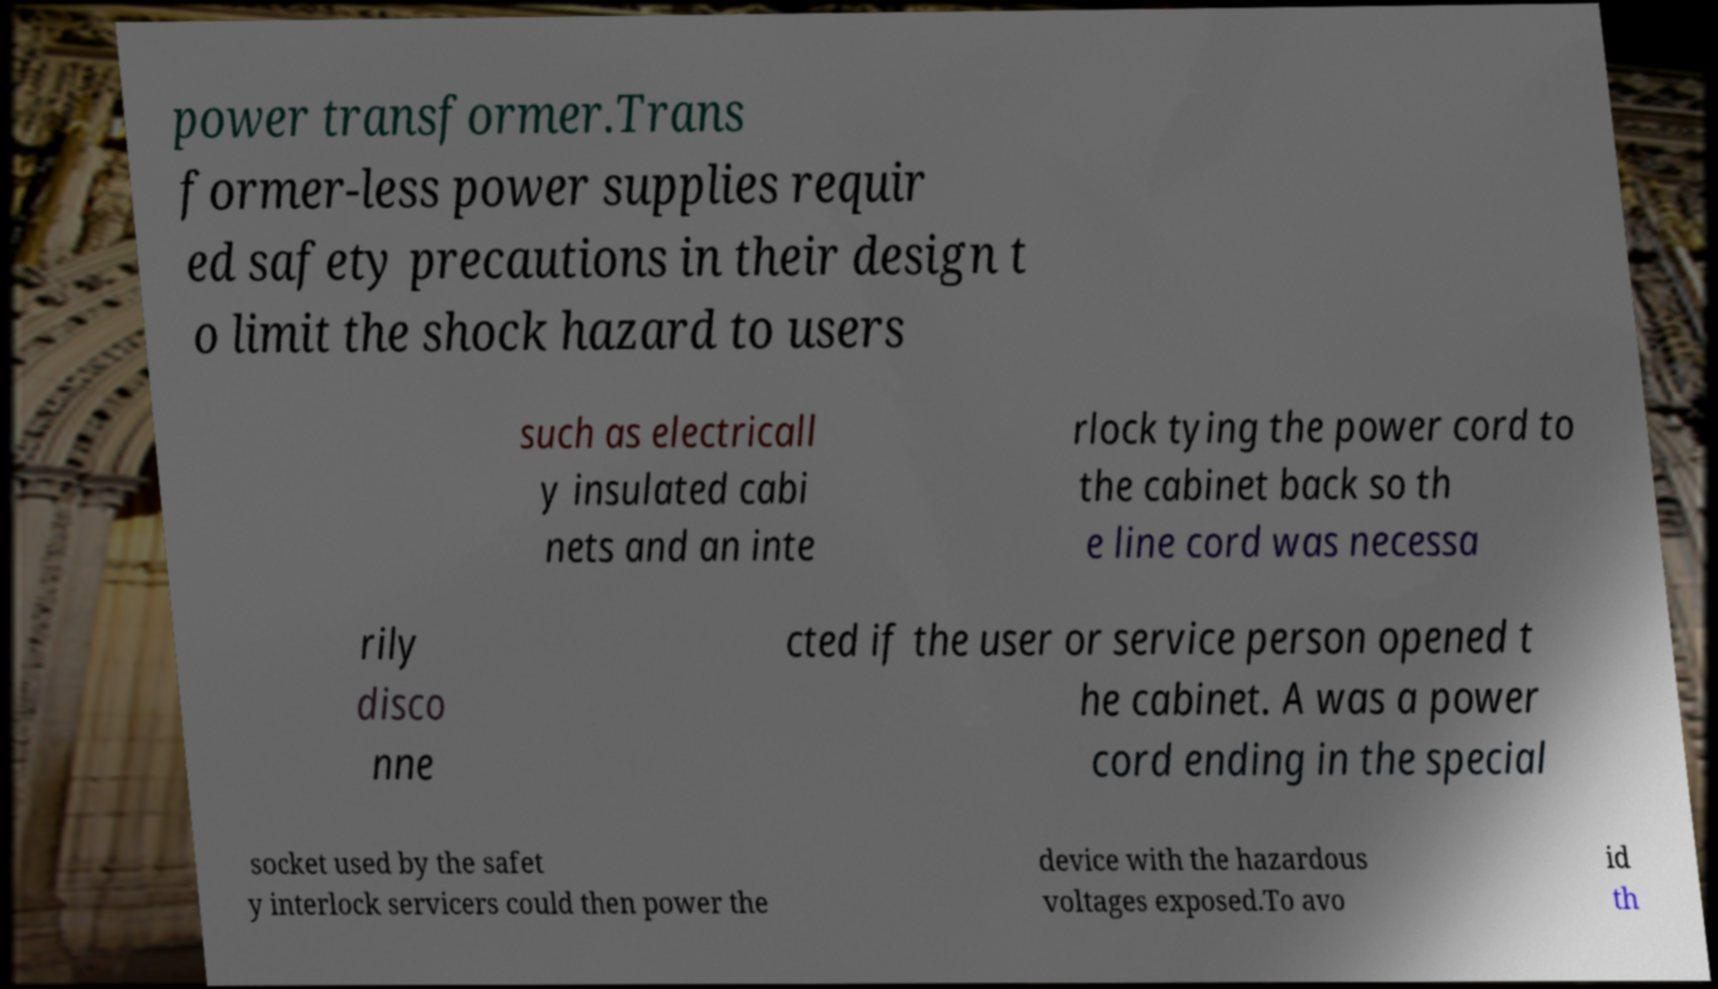Can you read and provide the text displayed in the image?This photo seems to have some interesting text. Can you extract and type it out for me? power transformer.Trans former-less power supplies requir ed safety precautions in their design t o limit the shock hazard to users such as electricall y insulated cabi nets and an inte rlock tying the power cord to the cabinet back so th e line cord was necessa rily disco nne cted if the user or service person opened t he cabinet. A was a power cord ending in the special socket used by the safet y interlock servicers could then power the device with the hazardous voltages exposed.To avo id th 